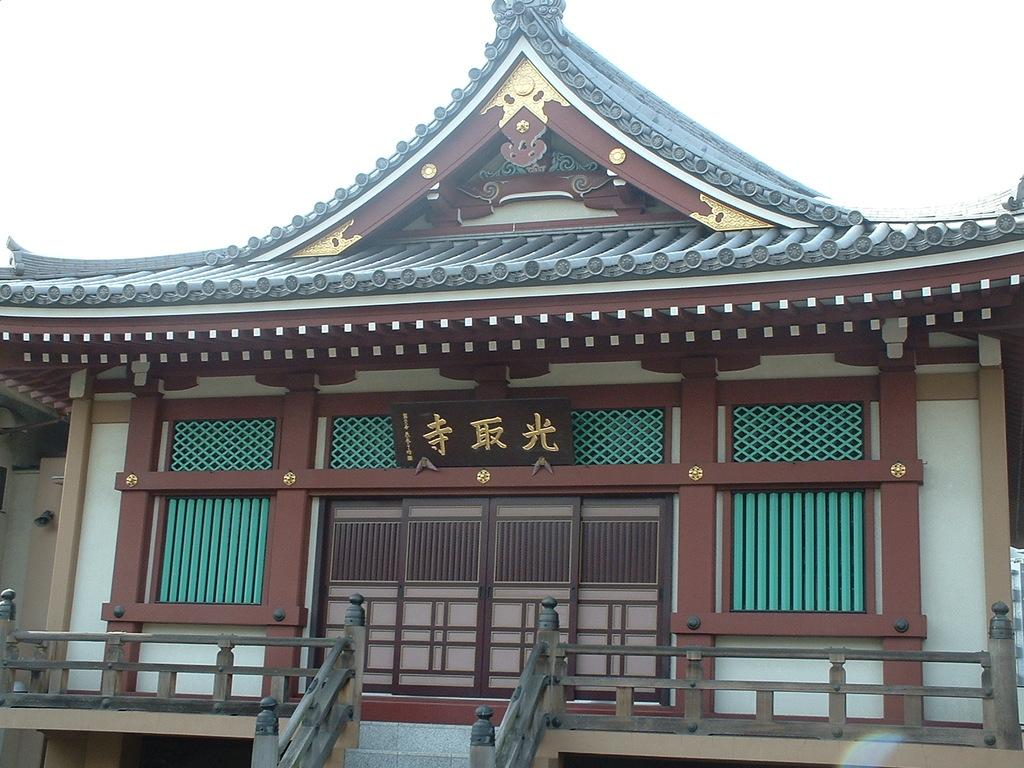What is the main subject in the center of the image? There is a building in the center of the image. What can be seen in the background of the image? The sky is visible in the background of the image. Where is the baby using the toothbrush in the image? There is no baby or toothbrush present in the image. 